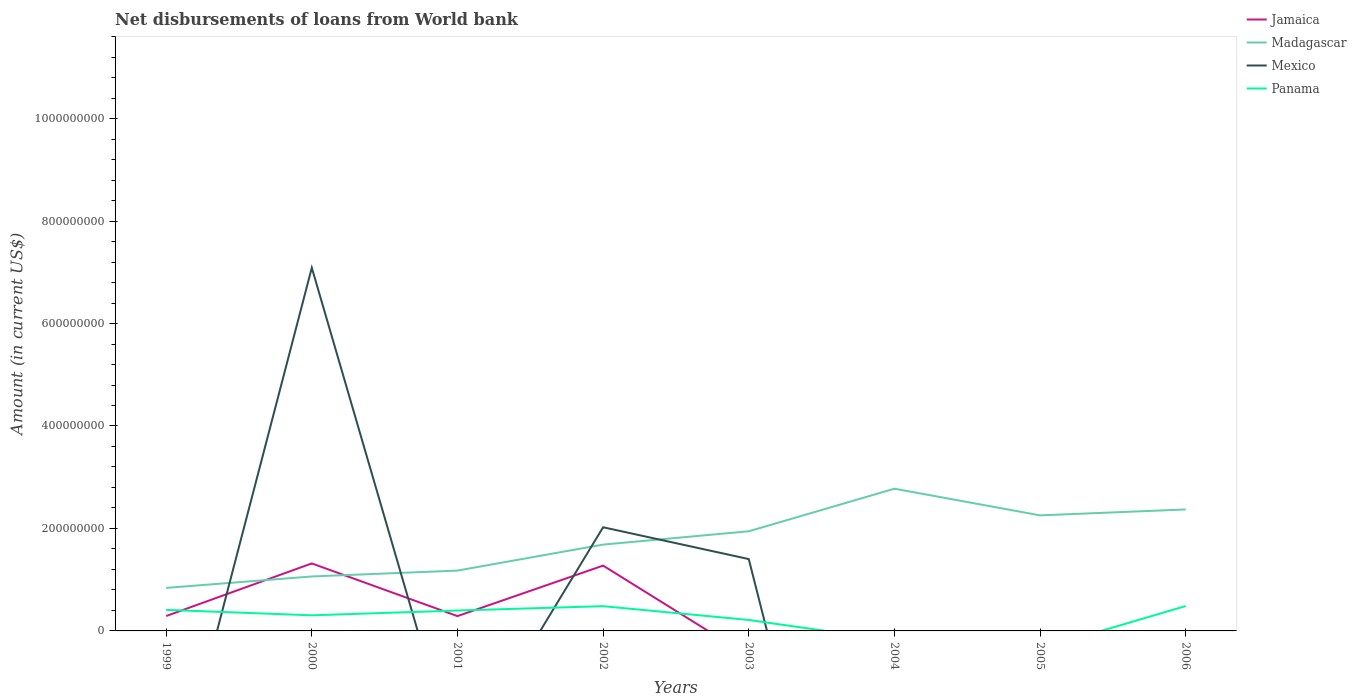Is the number of lines equal to the number of legend labels?
Provide a succinct answer. No. Across all years, what is the maximum amount of loan disbursed from World Bank in Mexico?
Ensure brevity in your answer.  0. What is the total amount of loan disbursed from World Bank in Panama in the graph?
Give a very brief answer. -7.54e+06. What is the difference between the highest and the second highest amount of loan disbursed from World Bank in Madagascar?
Offer a very short reply. 1.94e+08. What is the difference between two consecutive major ticks on the Y-axis?
Provide a short and direct response. 2.00e+08. Are the values on the major ticks of Y-axis written in scientific E-notation?
Give a very brief answer. No. Does the graph contain grids?
Your answer should be very brief. No. Where does the legend appear in the graph?
Your answer should be compact. Top right. What is the title of the graph?
Your response must be concise. Net disbursements of loans from World bank. Does "Serbia" appear as one of the legend labels in the graph?
Ensure brevity in your answer.  No. What is the label or title of the Y-axis?
Your response must be concise. Amount (in current US$). What is the Amount (in current US$) in Jamaica in 1999?
Your answer should be compact. 2.91e+07. What is the Amount (in current US$) of Madagascar in 1999?
Offer a very short reply. 8.40e+07. What is the Amount (in current US$) of Mexico in 1999?
Offer a very short reply. 0. What is the Amount (in current US$) in Panama in 1999?
Your response must be concise. 4.11e+07. What is the Amount (in current US$) in Jamaica in 2000?
Your response must be concise. 1.32e+08. What is the Amount (in current US$) of Madagascar in 2000?
Provide a short and direct response. 1.06e+08. What is the Amount (in current US$) in Mexico in 2000?
Your response must be concise. 7.09e+08. What is the Amount (in current US$) of Panama in 2000?
Offer a very short reply. 3.05e+07. What is the Amount (in current US$) in Jamaica in 2001?
Your answer should be compact. 2.89e+07. What is the Amount (in current US$) of Madagascar in 2001?
Your response must be concise. 1.18e+08. What is the Amount (in current US$) in Mexico in 2001?
Your response must be concise. 0. What is the Amount (in current US$) in Panama in 2001?
Provide a succinct answer. 3.98e+07. What is the Amount (in current US$) of Jamaica in 2002?
Offer a terse response. 1.27e+08. What is the Amount (in current US$) of Madagascar in 2002?
Ensure brevity in your answer.  1.69e+08. What is the Amount (in current US$) of Mexico in 2002?
Your answer should be compact. 2.02e+08. What is the Amount (in current US$) in Panama in 2002?
Make the answer very short. 4.83e+07. What is the Amount (in current US$) of Madagascar in 2003?
Keep it short and to the point. 1.94e+08. What is the Amount (in current US$) of Mexico in 2003?
Your response must be concise. 1.40e+08. What is the Amount (in current US$) in Panama in 2003?
Provide a short and direct response. 2.14e+07. What is the Amount (in current US$) in Jamaica in 2004?
Offer a terse response. 4.74e+05. What is the Amount (in current US$) in Madagascar in 2004?
Your answer should be very brief. 2.78e+08. What is the Amount (in current US$) in Mexico in 2004?
Your answer should be compact. 0. What is the Amount (in current US$) in Jamaica in 2005?
Make the answer very short. 0. What is the Amount (in current US$) of Madagascar in 2005?
Provide a succinct answer. 2.26e+08. What is the Amount (in current US$) of Mexico in 2005?
Your response must be concise. 0. What is the Amount (in current US$) of Jamaica in 2006?
Your answer should be very brief. 0. What is the Amount (in current US$) of Madagascar in 2006?
Your response must be concise. 2.37e+08. What is the Amount (in current US$) of Mexico in 2006?
Offer a terse response. 0. What is the Amount (in current US$) of Panama in 2006?
Offer a terse response. 4.86e+07. Across all years, what is the maximum Amount (in current US$) in Jamaica?
Keep it short and to the point. 1.32e+08. Across all years, what is the maximum Amount (in current US$) in Madagascar?
Your answer should be compact. 2.78e+08. Across all years, what is the maximum Amount (in current US$) in Mexico?
Give a very brief answer. 7.09e+08. Across all years, what is the maximum Amount (in current US$) in Panama?
Provide a succinct answer. 4.86e+07. Across all years, what is the minimum Amount (in current US$) of Jamaica?
Provide a succinct answer. 0. Across all years, what is the minimum Amount (in current US$) in Madagascar?
Offer a terse response. 8.40e+07. Across all years, what is the minimum Amount (in current US$) in Mexico?
Provide a succinct answer. 0. Across all years, what is the minimum Amount (in current US$) in Panama?
Ensure brevity in your answer.  0. What is the total Amount (in current US$) in Jamaica in the graph?
Provide a succinct answer. 3.18e+08. What is the total Amount (in current US$) in Madagascar in the graph?
Offer a terse response. 1.41e+09. What is the total Amount (in current US$) in Mexico in the graph?
Give a very brief answer. 1.05e+09. What is the total Amount (in current US$) in Panama in the graph?
Give a very brief answer. 2.30e+08. What is the difference between the Amount (in current US$) in Jamaica in 1999 and that in 2000?
Keep it short and to the point. -1.03e+08. What is the difference between the Amount (in current US$) in Madagascar in 1999 and that in 2000?
Make the answer very short. -2.23e+07. What is the difference between the Amount (in current US$) of Panama in 1999 and that in 2000?
Make the answer very short. 1.06e+07. What is the difference between the Amount (in current US$) in Jamaica in 1999 and that in 2001?
Make the answer very short. 1.18e+05. What is the difference between the Amount (in current US$) in Madagascar in 1999 and that in 2001?
Offer a terse response. -3.38e+07. What is the difference between the Amount (in current US$) in Panama in 1999 and that in 2001?
Make the answer very short. 1.25e+06. What is the difference between the Amount (in current US$) of Jamaica in 1999 and that in 2002?
Keep it short and to the point. -9.84e+07. What is the difference between the Amount (in current US$) in Madagascar in 1999 and that in 2002?
Give a very brief answer. -8.46e+07. What is the difference between the Amount (in current US$) of Panama in 1999 and that in 2002?
Offer a very short reply. -7.21e+06. What is the difference between the Amount (in current US$) in Madagascar in 1999 and that in 2003?
Provide a short and direct response. -1.11e+08. What is the difference between the Amount (in current US$) of Panama in 1999 and that in 2003?
Provide a short and direct response. 1.97e+07. What is the difference between the Amount (in current US$) in Jamaica in 1999 and that in 2004?
Make the answer very short. 2.86e+07. What is the difference between the Amount (in current US$) in Madagascar in 1999 and that in 2004?
Your answer should be compact. -1.94e+08. What is the difference between the Amount (in current US$) of Madagascar in 1999 and that in 2005?
Your answer should be very brief. -1.42e+08. What is the difference between the Amount (in current US$) of Madagascar in 1999 and that in 2006?
Provide a short and direct response. -1.53e+08. What is the difference between the Amount (in current US$) of Panama in 1999 and that in 2006?
Keep it short and to the point. -7.54e+06. What is the difference between the Amount (in current US$) of Jamaica in 2000 and that in 2001?
Offer a very short reply. 1.03e+08. What is the difference between the Amount (in current US$) of Madagascar in 2000 and that in 2001?
Give a very brief answer. -1.15e+07. What is the difference between the Amount (in current US$) in Panama in 2000 and that in 2001?
Give a very brief answer. -9.33e+06. What is the difference between the Amount (in current US$) in Jamaica in 2000 and that in 2002?
Your answer should be compact. 4.26e+06. What is the difference between the Amount (in current US$) in Madagascar in 2000 and that in 2002?
Offer a terse response. -6.22e+07. What is the difference between the Amount (in current US$) in Mexico in 2000 and that in 2002?
Your response must be concise. 5.07e+08. What is the difference between the Amount (in current US$) in Panama in 2000 and that in 2002?
Give a very brief answer. -1.78e+07. What is the difference between the Amount (in current US$) in Madagascar in 2000 and that in 2003?
Your response must be concise. -8.82e+07. What is the difference between the Amount (in current US$) of Mexico in 2000 and that in 2003?
Ensure brevity in your answer.  5.69e+08. What is the difference between the Amount (in current US$) of Panama in 2000 and that in 2003?
Offer a terse response. 9.08e+06. What is the difference between the Amount (in current US$) of Jamaica in 2000 and that in 2004?
Your answer should be compact. 1.31e+08. What is the difference between the Amount (in current US$) of Madagascar in 2000 and that in 2004?
Make the answer very short. -1.71e+08. What is the difference between the Amount (in current US$) in Madagascar in 2000 and that in 2005?
Offer a very short reply. -1.19e+08. What is the difference between the Amount (in current US$) in Madagascar in 2000 and that in 2006?
Offer a terse response. -1.31e+08. What is the difference between the Amount (in current US$) in Panama in 2000 and that in 2006?
Offer a very short reply. -1.81e+07. What is the difference between the Amount (in current US$) in Jamaica in 2001 and that in 2002?
Your answer should be compact. -9.85e+07. What is the difference between the Amount (in current US$) in Madagascar in 2001 and that in 2002?
Give a very brief answer. -5.07e+07. What is the difference between the Amount (in current US$) of Panama in 2001 and that in 2002?
Your response must be concise. -8.46e+06. What is the difference between the Amount (in current US$) of Madagascar in 2001 and that in 2003?
Provide a succinct answer. -7.67e+07. What is the difference between the Amount (in current US$) in Panama in 2001 and that in 2003?
Your answer should be compact. 1.84e+07. What is the difference between the Amount (in current US$) in Jamaica in 2001 and that in 2004?
Make the answer very short. 2.85e+07. What is the difference between the Amount (in current US$) in Madagascar in 2001 and that in 2004?
Your response must be concise. -1.60e+08. What is the difference between the Amount (in current US$) in Madagascar in 2001 and that in 2005?
Keep it short and to the point. -1.08e+08. What is the difference between the Amount (in current US$) in Madagascar in 2001 and that in 2006?
Your response must be concise. -1.19e+08. What is the difference between the Amount (in current US$) of Panama in 2001 and that in 2006?
Make the answer very short. -8.79e+06. What is the difference between the Amount (in current US$) of Madagascar in 2002 and that in 2003?
Your answer should be compact. -2.60e+07. What is the difference between the Amount (in current US$) in Mexico in 2002 and that in 2003?
Your answer should be compact. 6.21e+07. What is the difference between the Amount (in current US$) of Panama in 2002 and that in 2003?
Offer a terse response. 2.69e+07. What is the difference between the Amount (in current US$) of Jamaica in 2002 and that in 2004?
Keep it short and to the point. 1.27e+08. What is the difference between the Amount (in current US$) in Madagascar in 2002 and that in 2004?
Your answer should be very brief. -1.09e+08. What is the difference between the Amount (in current US$) in Madagascar in 2002 and that in 2005?
Your response must be concise. -5.71e+07. What is the difference between the Amount (in current US$) of Madagascar in 2002 and that in 2006?
Your response must be concise. -6.86e+07. What is the difference between the Amount (in current US$) of Panama in 2002 and that in 2006?
Provide a succinct answer. -3.28e+05. What is the difference between the Amount (in current US$) in Madagascar in 2003 and that in 2004?
Offer a very short reply. -8.32e+07. What is the difference between the Amount (in current US$) of Madagascar in 2003 and that in 2005?
Your answer should be very brief. -3.11e+07. What is the difference between the Amount (in current US$) of Madagascar in 2003 and that in 2006?
Offer a terse response. -4.26e+07. What is the difference between the Amount (in current US$) in Panama in 2003 and that in 2006?
Your answer should be compact. -2.72e+07. What is the difference between the Amount (in current US$) of Madagascar in 2004 and that in 2005?
Your answer should be very brief. 5.21e+07. What is the difference between the Amount (in current US$) in Madagascar in 2004 and that in 2006?
Your response must be concise. 4.05e+07. What is the difference between the Amount (in current US$) in Madagascar in 2005 and that in 2006?
Offer a terse response. -1.15e+07. What is the difference between the Amount (in current US$) of Jamaica in 1999 and the Amount (in current US$) of Madagascar in 2000?
Offer a very short reply. -7.72e+07. What is the difference between the Amount (in current US$) in Jamaica in 1999 and the Amount (in current US$) in Mexico in 2000?
Provide a succinct answer. -6.80e+08. What is the difference between the Amount (in current US$) in Jamaica in 1999 and the Amount (in current US$) in Panama in 2000?
Your answer should be very brief. -1.42e+06. What is the difference between the Amount (in current US$) in Madagascar in 1999 and the Amount (in current US$) in Mexico in 2000?
Offer a very short reply. -6.25e+08. What is the difference between the Amount (in current US$) of Madagascar in 1999 and the Amount (in current US$) of Panama in 2000?
Ensure brevity in your answer.  5.35e+07. What is the difference between the Amount (in current US$) in Jamaica in 1999 and the Amount (in current US$) in Madagascar in 2001?
Give a very brief answer. -8.87e+07. What is the difference between the Amount (in current US$) of Jamaica in 1999 and the Amount (in current US$) of Panama in 2001?
Provide a succinct answer. -1.07e+07. What is the difference between the Amount (in current US$) of Madagascar in 1999 and the Amount (in current US$) of Panama in 2001?
Provide a succinct answer. 4.42e+07. What is the difference between the Amount (in current US$) in Jamaica in 1999 and the Amount (in current US$) in Madagascar in 2002?
Provide a succinct answer. -1.39e+08. What is the difference between the Amount (in current US$) of Jamaica in 1999 and the Amount (in current US$) of Mexico in 2002?
Offer a very short reply. -1.73e+08. What is the difference between the Amount (in current US$) in Jamaica in 1999 and the Amount (in current US$) in Panama in 2002?
Offer a very short reply. -1.92e+07. What is the difference between the Amount (in current US$) of Madagascar in 1999 and the Amount (in current US$) of Mexico in 2002?
Your answer should be compact. -1.18e+08. What is the difference between the Amount (in current US$) of Madagascar in 1999 and the Amount (in current US$) of Panama in 2002?
Keep it short and to the point. 3.57e+07. What is the difference between the Amount (in current US$) in Jamaica in 1999 and the Amount (in current US$) in Madagascar in 2003?
Offer a very short reply. -1.65e+08. What is the difference between the Amount (in current US$) of Jamaica in 1999 and the Amount (in current US$) of Mexico in 2003?
Give a very brief answer. -1.11e+08. What is the difference between the Amount (in current US$) of Jamaica in 1999 and the Amount (in current US$) of Panama in 2003?
Your response must be concise. 7.66e+06. What is the difference between the Amount (in current US$) in Madagascar in 1999 and the Amount (in current US$) in Mexico in 2003?
Offer a terse response. -5.63e+07. What is the difference between the Amount (in current US$) of Madagascar in 1999 and the Amount (in current US$) of Panama in 2003?
Keep it short and to the point. 6.26e+07. What is the difference between the Amount (in current US$) of Jamaica in 1999 and the Amount (in current US$) of Madagascar in 2004?
Make the answer very short. -2.49e+08. What is the difference between the Amount (in current US$) in Jamaica in 1999 and the Amount (in current US$) in Madagascar in 2005?
Your answer should be very brief. -1.97e+08. What is the difference between the Amount (in current US$) of Jamaica in 1999 and the Amount (in current US$) of Madagascar in 2006?
Ensure brevity in your answer.  -2.08e+08. What is the difference between the Amount (in current US$) of Jamaica in 1999 and the Amount (in current US$) of Panama in 2006?
Give a very brief answer. -1.95e+07. What is the difference between the Amount (in current US$) of Madagascar in 1999 and the Amount (in current US$) of Panama in 2006?
Keep it short and to the point. 3.54e+07. What is the difference between the Amount (in current US$) in Jamaica in 2000 and the Amount (in current US$) in Madagascar in 2001?
Your response must be concise. 1.40e+07. What is the difference between the Amount (in current US$) in Jamaica in 2000 and the Amount (in current US$) in Panama in 2001?
Offer a very short reply. 9.20e+07. What is the difference between the Amount (in current US$) of Madagascar in 2000 and the Amount (in current US$) of Panama in 2001?
Offer a very short reply. 6.65e+07. What is the difference between the Amount (in current US$) in Mexico in 2000 and the Amount (in current US$) in Panama in 2001?
Offer a very short reply. 6.69e+08. What is the difference between the Amount (in current US$) of Jamaica in 2000 and the Amount (in current US$) of Madagascar in 2002?
Ensure brevity in your answer.  -3.68e+07. What is the difference between the Amount (in current US$) in Jamaica in 2000 and the Amount (in current US$) in Mexico in 2002?
Keep it short and to the point. -7.06e+07. What is the difference between the Amount (in current US$) in Jamaica in 2000 and the Amount (in current US$) in Panama in 2002?
Offer a terse response. 8.35e+07. What is the difference between the Amount (in current US$) in Madagascar in 2000 and the Amount (in current US$) in Mexico in 2002?
Offer a very short reply. -9.60e+07. What is the difference between the Amount (in current US$) in Madagascar in 2000 and the Amount (in current US$) in Panama in 2002?
Keep it short and to the point. 5.80e+07. What is the difference between the Amount (in current US$) in Mexico in 2000 and the Amount (in current US$) in Panama in 2002?
Provide a short and direct response. 6.61e+08. What is the difference between the Amount (in current US$) in Jamaica in 2000 and the Amount (in current US$) in Madagascar in 2003?
Provide a succinct answer. -6.27e+07. What is the difference between the Amount (in current US$) of Jamaica in 2000 and the Amount (in current US$) of Mexico in 2003?
Your answer should be very brief. -8.49e+06. What is the difference between the Amount (in current US$) of Jamaica in 2000 and the Amount (in current US$) of Panama in 2003?
Provide a short and direct response. 1.10e+08. What is the difference between the Amount (in current US$) in Madagascar in 2000 and the Amount (in current US$) in Mexico in 2003?
Your answer should be very brief. -3.39e+07. What is the difference between the Amount (in current US$) in Madagascar in 2000 and the Amount (in current US$) in Panama in 2003?
Provide a short and direct response. 8.49e+07. What is the difference between the Amount (in current US$) of Mexico in 2000 and the Amount (in current US$) of Panama in 2003?
Your response must be concise. 6.87e+08. What is the difference between the Amount (in current US$) in Jamaica in 2000 and the Amount (in current US$) in Madagascar in 2004?
Offer a terse response. -1.46e+08. What is the difference between the Amount (in current US$) of Jamaica in 2000 and the Amount (in current US$) of Madagascar in 2005?
Your answer should be very brief. -9.38e+07. What is the difference between the Amount (in current US$) in Jamaica in 2000 and the Amount (in current US$) in Madagascar in 2006?
Your response must be concise. -1.05e+08. What is the difference between the Amount (in current US$) of Jamaica in 2000 and the Amount (in current US$) of Panama in 2006?
Offer a very short reply. 8.32e+07. What is the difference between the Amount (in current US$) in Madagascar in 2000 and the Amount (in current US$) in Panama in 2006?
Offer a very short reply. 5.77e+07. What is the difference between the Amount (in current US$) of Mexico in 2000 and the Amount (in current US$) of Panama in 2006?
Keep it short and to the point. 6.60e+08. What is the difference between the Amount (in current US$) of Jamaica in 2001 and the Amount (in current US$) of Madagascar in 2002?
Give a very brief answer. -1.40e+08. What is the difference between the Amount (in current US$) in Jamaica in 2001 and the Amount (in current US$) in Mexico in 2002?
Keep it short and to the point. -1.73e+08. What is the difference between the Amount (in current US$) of Jamaica in 2001 and the Amount (in current US$) of Panama in 2002?
Keep it short and to the point. -1.93e+07. What is the difference between the Amount (in current US$) of Madagascar in 2001 and the Amount (in current US$) of Mexico in 2002?
Your answer should be very brief. -8.46e+07. What is the difference between the Amount (in current US$) of Madagascar in 2001 and the Amount (in current US$) of Panama in 2002?
Give a very brief answer. 6.95e+07. What is the difference between the Amount (in current US$) of Jamaica in 2001 and the Amount (in current US$) of Madagascar in 2003?
Keep it short and to the point. -1.66e+08. What is the difference between the Amount (in current US$) in Jamaica in 2001 and the Amount (in current US$) in Mexico in 2003?
Offer a terse response. -1.11e+08. What is the difference between the Amount (in current US$) of Jamaica in 2001 and the Amount (in current US$) of Panama in 2003?
Give a very brief answer. 7.54e+06. What is the difference between the Amount (in current US$) in Madagascar in 2001 and the Amount (in current US$) in Mexico in 2003?
Give a very brief answer. -2.25e+07. What is the difference between the Amount (in current US$) in Madagascar in 2001 and the Amount (in current US$) in Panama in 2003?
Your answer should be compact. 9.64e+07. What is the difference between the Amount (in current US$) in Jamaica in 2001 and the Amount (in current US$) in Madagascar in 2004?
Your response must be concise. -2.49e+08. What is the difference between the Amount (in current US$) in Jamaica in 2001 and the Amount (in current US$) in Madagascar in 2005?
Offer a very short reply. -1.97e+08. What is the difference between the Amount (in current US$) of Jamaica in 2001 and the Amount (in current US$) of Madagascar in 2006?
Keep it short and to the point. -2.08e+08. What is the difference between the Amount (in current US$) in Jamaica in 2001 and the Amount (in current US$) in Panama in 2006?
Your answer should be very brief. -1.97e+07. What is the difference between the Amount (in current US$) in Madagascar in 2001 and the Amount (in current US$) in Panama in 2006?
Your answer should be very brief. 6.92e+07. What is the difference between the Amount (in current US$) in Jamaica in 2002 and the Amount (in current US$) in Madagascar in 2003?
Provide a short and direct response. -6.70e+07. What is the difference between the Amount (in current US$) in Jamaica in 2002 and the Amount (in current US$) in Mexico in 2003?
Offer a very short reply. -1.28e+07. What is the difference between the Amount (in current US$) of Jamaica in 2002 and the Amount (in current US$) of Panama in 2003?
Offer a very short reply. 1.06e+08. What is the difference between the Amount (in current US$) in Madagascar in 2002 and the Amount (in current US$) in Mexico in 2003?
Your answer should be compact. 2.83e+07. What is the difference between the Amount (in current US$) of Madagascar in 2002 and the Amount (in current US$) of Panama in 2003?
Keep it short and to the point. 1.47e+08. What is the difference between the Amount (in current US$) of Mexico in 2002 and the Amount (in current US$) of Panama in 2003?
Provide a short and direct response. 1.81e+08. What is the difference between the Amount (in current US$) of Jamaica in 2002 and the Amount (in current US$) of Madagascar in 2004?
Keep it short and to the point. -1.50e+08. What is the difference between the Amount (in current US$) of Jamaica in 2002 and the Amount (in current US$) of Madagascar in 2005?
Your answer should be compact. -9.81e+07. What is the difference between the Amount (in current US$) in Jamaica in 2002 and the Amount (in current US$) in Madagascar in 2006?
Your answer should be compact. -1.10e+08. What is the difference between the Amount (in current US$) in Jamaica in 2002 and the Amount (in current US$) in Panama in 2006?
Make the answer very short. 7.89e+07. What is the difference between the Amount (in current US$) of Madagascar in 2002 and the Amount (in current US$) of Panama in 2006?
Ensure brevity in your answer.  1.20e+08. What is the difference between the Amount (in current US$) in Mexico in 2002 and the Amount (in current US$) in Panama in 2006?
Offer a very short reply. 1.54e+08. What is the difference between the Amount (in current US$) in Madagascar in 2003 and the Amount (in current US$) in Panama in 2006?
Keep it short and to the point. 1.46e+08. What is the difference between the Amount (in current US$) of Mexico in 2003 and the Amount (in current US$) of Panama in 2006?
Make the answer very short. 9.17e+07. What is the difference between the Amount (in current US$) of Jamaica in 2004 and the Amount (in current US$) of Madagascar in 2005?
Provide a short and direct response. -2.25e+08. What is the difference between the Amount (in current US$) in Jamaica in 2004 and the Amount (in current US$) in Madagascar in 2006?
Your answer should be compact. -2.37e+08. What is the difference between the Amount (in current US$) of Jamaica in 2004 and the Amount (in current US$) of Panama in 2006?
Offer a very short reply. -4.81e+07. What is the difference between the Amount (in current US$) of Madagascar in 2004 and the Amount (in current US$) of Panama in 2006?
Your response must be concise. 2.29e+08. What is the difference between the Amount (in current US$) of Madagascar in 2005 and the Amount (in current US$) of Panama in 2006?
Offer a very short reply. 1.77e+08. What is the average Amount (in current US$) of Jamaica per year?
Your answer should be very brief. 3.97e+07. What is the average Amount (in current US$) in Madagascar per year?
Offer a very short reply. 1.76e+08. What is the average Amount (in current US$) of Mexico per year?
Make the answer very short. 1.31e+08. What is the average Amount (in current US$) in Panama per year?
Your answer should be very brief. 2.87e+07. In the year 1999, what is the difference between the Amount (in current US$) of Jamaica and Amount (in current US$) of Madagascar?
Provide a short and direct response. -5.49e+07. In the year 1999, what is the difference between the Amount (in current US$) in Jamaica and Amount (in current US$) in Panama?
Offer a very short reply. -1.20e+07. In the year 1999, what is the difference between the Amount (in current US$) of Madagascar and Amount (in current US$) of Panama?
Your response must be concise. 4.29e+07. In the year 2000, what is the difference between the Amount (in current US$) of Jamaica and Amount (in current US$) of Madagascar?
Offer a very short reply. 2.55e+07. In the year 2000, what is the difference between the Amount (in current US$) of Jamaica and Amount (in current US$) of Mexico?
Your answer should be compact. -5.77e+08. In the year 2000, what is the difference between the Amount (in current US$) of Jamaica and Amount (in current US$) of Panama?
Provide a short and direct response. 1.01e+08. In the year 2000, what is the difference between the Amount (in current US$) of Madagascar and Amount (in current US$) of Mexico?
Offer a very short reply. -6.03e+08. In the year 2000, what is the difference between the Amount (in current US$) of Madagascar and Amount (in current US$) of Panama?
Your answer should be very brief. 7.58e+07. In the year 2000, what is the difference between the Amount (in current US$) in Mexico and Amount (in current US$) in Panama?
Offer a terse response. 6.78e+08. In the year 2001, what is the difference between the Amount (in current US$) in Jamaica and Amount (in current US$) in Madagascar?
Your answer should be compact. -8.88e+07. In the year 2001, what is the difference between the Amount (in current US$) in Jamaica and Amount (in current US$) in Panama?
Your answer should be very brief. -1.09e+07. In the year 2001, what is the difference between the Amount (in current US$) in Madagascar and Amount (in current US$) in Panama?
Offer a terse response. 7.80e+07. In the year 2002, what is the difference between the Amount (in current US$) in Jamaica and Amount (in current US$) in Madagascar?
Your answer should be compact. -4.10e+07. In the year 2002, what is the difference between the Amount (in current US$) in Jamaica and Amount (in current US$) in Mexico?
Ensure brevity in your answer.  -7.49e+07. In the year 2002, what is the difference between the Amount (in current US$) of Jamaica and Amount (in current US$) of Panama?
Ensure brevity in your answer.  7.92e+07. In the year 2002, what is the difference between the Amount (in current US$) of Madagascar and Amount (in current US$) of Mexico?
Provide a succinct answer. -3.38e+07. In the year 2002, what is the difference between the Amount (in current US$) of Madagascar and Amount (in current US$) of Panama?
Keep it short and to the point. 1.20e+08. In the year 2002, what is the difference between the Amount (in current US$) in Mexico and Amount (in current US$) in Panama?
Your response must be concise. 1.54e+08. In the year 2003, what is the difference between the Amount (in current US$) in Madagascar and Amount (in current US$) in Mexico?
Provide a succinct answer. 5.42e+07. In the year 2003, what is the difference between the Amount (in current US$) in Madagascar and Amount (in current US$) in Panama?
Your answer should be very brief. 1.73e+08. In the year 2003, what is the difference between the Amount (in current US$) of Mexico and Amount (in current US$) of Panama?
Offer a very short reply. 1.19e+08. In the year 2004, what is the difference between the Amount (in current US$) in Jamaica and Amount (in current US$) in Madagascar?
Offer a terse response. -2.77e+08. In the year 2006, what is the difference between the Amount (in current US$) in Madagascar and Amount (in current US$) in Panama?
Make the answer very short. 1.89e+08. What is the ratio of the Amount (in current US$) of Jamaica in 1999 to that in 2000?
Ensure brevity in your answer.  0.22. What is the ratio of the Amount (in current US$) of Madagascar in 1999 to that in 2000?
Keep it short and to the point. 0.79. What is the ratio of the Amount (in current US$) in Panama in 1999 to that in 2000?
Give a very brief answer. 1.35. What is the ratio of the Amount (in current US$) of Jamaica in 1999 to that in 2001?
Provide a succinct answer. 1. What is the ratio of the Amount (in current US$) of Madagascar in 1999 to that in 2001?
Your response must be concise. 0.71. What is the ratio of the Amount (in current US$) of Panama in 1999 to that in 2001?
Offer a very short reply. 1.03. What is the ratio of the Amount (in current US$) of Jamaica in 1999 to that in 2002?
Provide a succinct answer. 0.23. What is the ratio of the Amount (in current US$) in Madagascar in 1999 to that in 2002?
Offer a very short reply. 0.5. What is the ratio of the Amount (in current US$) in Panama in 1999 to that in 2002?
Provide a succinct answer. 0.85. What is the ratio of the Amount (in current US$) in Madagascar in 1999 to that in 2003?
Provide a short and direct response. 0.43. What is the ratio of the Amount (in current US$) in Panama in 1999 to that in 2003?
Your answer should be compact. 1.92. What is the ratio of the Amount (in current US$) of Jamaica in 1999 to that in 2004?
Give a very brief answer. 61.31. What is the ratio of the Amount (in current US$) of Madagascar in 1999 to that in 2004?
Your response must be concise. 0.3. What is the ratio of the Amount (in current US$) in Madagascar in 1999 to that in 2005?
Give a very brief answer. 0.37. What is the ratio of the Amount (in current US$) in Madagascar in 1999 to that in 2006?
Keep it short and to the point. 0.35. What is the ratio of the Amount (in current US$) of Panama in 1999 to that in 2006?
Offer a very short reply. 0.84. What is the ratio of the Amount (in current US$) of Jamaica in 2000 to that in 2001?
Give a very brief answer. 4.55. What is the ratio of the Amount (in current US$) in Madagascar in 2000 to that in 2001?
Give a very brief answer. 0.9. What is the ratio of the Amount (in current US$) of Panama in 2000 to that in 2001?
Your answer should be very brief. 0.77. What is the ratio of the Amount (in current US$) in Jamaica in 2000 to that in 2002?
Your response must be concise. 1.03. What is the ratio of the Amount (in current US$) in Madagascar in 2000 to that in 2002?
Provide a succinct answer. 0.63. What is the ratio of the Amount (in current US$) in Mexico in 2000 to that in 2002?
Ensure brevity in your answer.  3.5. What is the ratio of the Amount (in current US$) of Panama in 2000 to that in 2002?
Your response must be concise. 0.63. What is the ratio of the Amount (in current US$) of Madagascar in 2000 to that in 2003?
Your answer should be compact. 0.55. What is the ratio of the Amount (in current US$) in Mexico in 2000 to that in 2003?
Offer a terse response. 5.05. What is the ratio of the Amount (in current US$) of Panama in 2000 to that in 2003?
Offer a very short reply. 1.42. What is the ratio of the Amount (in current US$) of Jamaica in 2000 to that in 2004?
Give a very brief answer. 277.97. What is the ratio of the Amount (in current US$) of Madagascar in 2000 to that in 2004?
Offer a very short reply. 0.38. What is the ratio of the Amount (in current US$) of Madagascar in 2000 to that in 2005?
Offer a very short reply. 0.47. What is the ratio of the Amount (in current US$) of Madagascar in 2000 to that in 2006?
Provide a short and direct response. 0.45. What is the ratio of the Amount (in current US$) in Panama in 2000 to that in 2006?
Keep it short and to the point. 0.63. What is the ratio of the Amount (in current US$) in Jamaica in 2001 to that in 2002?
Give a very brief answer. 0.23. What is the ratio of the Amount (in current US$) in Madagascar in 2001 to that in 2002?
Make the answer very short. 0.7. What is the ratio of the Amount (in current US$) in Panama in 2001 to that in 2002?
Your response must be concise. 0.82. What is the ratio of the Amount (in current US$) in Madagascar in 2001 to that in 2003?
Provide a succinct answer. 0.61. What is the ratio of the Amount (in current US$) in Panama in 2001 to that in 2003?
Provide a short and direct response. 1.86. What is the ratio of the Amount (in current US$) of Jamaica in 2001 to that in 2004?
Provide a short and direct response. 61.07. What is the ratio of the Amount (in current US$) in Madagascar in 2001 to that in 2004?
Your response must be concise. 0.42. What is the ratio of the Amount (in current US$) of Madagascar in 2001 to that in 2005?
Your answer should be very brief. 0.52. What is the ratio of the Amount (in current US$) in Madagascar in 2001 to that in 2006?
Your response must be concise. 0.5. What is the ratio of the Amount (in current US$) of Panama in 2001 to that in 2006?
Your response must be concise. 0.82. What is the ratio of the Amount (in current US$) of Madagascar in 2002 to that in 2003?
Your answer should be compact. 0.87. What is the ratio of the Amount (in current US$) in Mexico in 2002 to that in 2003?
Offer a terse response. 1.44. What is the ratio of the Amount (in current US$) of Panama in 2002 to that in 2003?
Your response must be concise. 2.26. What is the ratio of the Amount (in current US$) of Jamaica in 2002 to that in 2004?
Provide a succinct answer. 268.97. What is the ratio of the Amount (in current US$) of Madagascar in 2002 to that in 2004?
Offer a terse response. 0.61. What is the ratio of the Amount (in current US$) in Madagascar in 2002 to that in 2005?
Provide a short and direct response. 0.75. What is the ratio of the Amount (in current US$) of Madagascar in 2002 to that in 2006?
Ensure brevity in your answer.  0.71. What is the ratio of the Amount (in current US$) in Panama in 2002 to that in 2006?
Your answer should be compact. 0.99. What is the ratio of the Amount (in current US$) in Madagascar in 2003 to that in 2004?
Your response must be concise. 0.7. What is the ratio of the Amount (in current US$) in Madagascar in 2003 to that in 2005?
Your answer should be very brief. 0.86. What is the ratio of the Amount (in current US$) in Madagascar in 2003 to that in 2006?
Offer a very short reply. 0.82. What is the ratio of the Amount (in current US$) in Panama in 2003 to that in 2006?
Provide a short and direct response. 0.44. What is the ratio of the Amount (in current US$) in Madagascar in 2004 to that in 2005?
Keep it short and to the point. 1.23. What is the ratio of the Amount (in current US$) in Madagascar in 2004 to that in 2006?
Provide a succinct answer. 1.17. What is the ratio of the Amount (in current US$) of Madagascar in 2005 to that in 2006?
Keep it short and to the point. 0.95. What is the difference between the highest and the second highest Amount (in current US$) in Jamaica?
Give a very brief answer. 4.26e+06. What is the difference between the highest and the second highest Amount (in current US$) in Madagascar?
Give a very brief answer. 4.05e+07. What is the difference between the highest and the second highest Amount (in current US$) in Mexico?
Your answer should be compact. 5.07e+08. What is the difference between the highest and the second highest Amount (in current US$) in Panama?
Your response must be concise. 3.28e+05. What is the difference between the highest and the lowest Amount (in current US$) in Jamaica?
Offer a terse response. 1.32e+08. What is the difference between the highest and the lowest Amount (in current US$) of Madagascar?
Your response must be concise. 1.94e+08. What is the difference between the highest and the lowest Amount (in current US$) of Mexico?
Offer a very short reply. 7.09e+08. What is the difference between the highest and the lowest Amount (in current US$) in Panama?
Provide a short and direct response. 4.86e+07. 